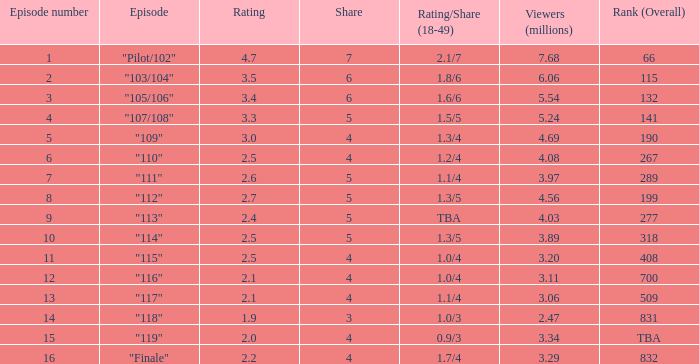Parse the table in full. {'header': ['Episode number', 'Episode', 'Rating', 'Share', 'Rating/Share (18-49)', 'Viewers (millions)', 'Rank (Overall)'], 'rows': [['1', '"Pilot/102"', '4.7', '7', '2.1/7', '7.68', '66'], ['2', '"103/104"', '3.5', '6', '1.8/6', '6.06', '115'], ['3', '"105/106"', '3.4', '6', '1.6/6', '5.54', '132'], ['4', '"107/108"', '3.3', '5', '1.5/5', '5.24', '141'], ['5', '"109"', '3.0', '4', '1.3/4', '4.69', '190'], ['6', '"110"', '2.5', '4', '1.2/4', '4.08', '267'], ['7', '"111"', '2.6', '5', '1.1/4', '3.97', '289'], ['8', '"112"', '2.7', '5', '1.3/5', '4.56', '199'], ['9', '"113"', '2.4', '5', 'TBA', '4.03', '277'], ['10', '"114"', '2.5', '5', '1.3/5', '3.89', '318'], ['11', '"115"', '2.5', '4', '1.0/4', '3.20', '408'], ['12', '"116"', '2.1', '4', '1.0/4', '3.11', '700'], ['13', '"117"', '2.1', '4', '1.1/4', '3.06', '509'], ['14', '"118"', '1.9', '3', '1.0/3', '2.47', '831'], ['15', '"119"', '2.0', '4', '0.9/3', '3.34', 'TBA'], ['16', '"Finale"', '2.2', '4', '1.7/4', '3.29', '832']]} WHAT IS THE HIGHEST VIEWERS WITH AN EPISODE LESS THAN 15 AND SHARE LAGER THAN 7? None. 